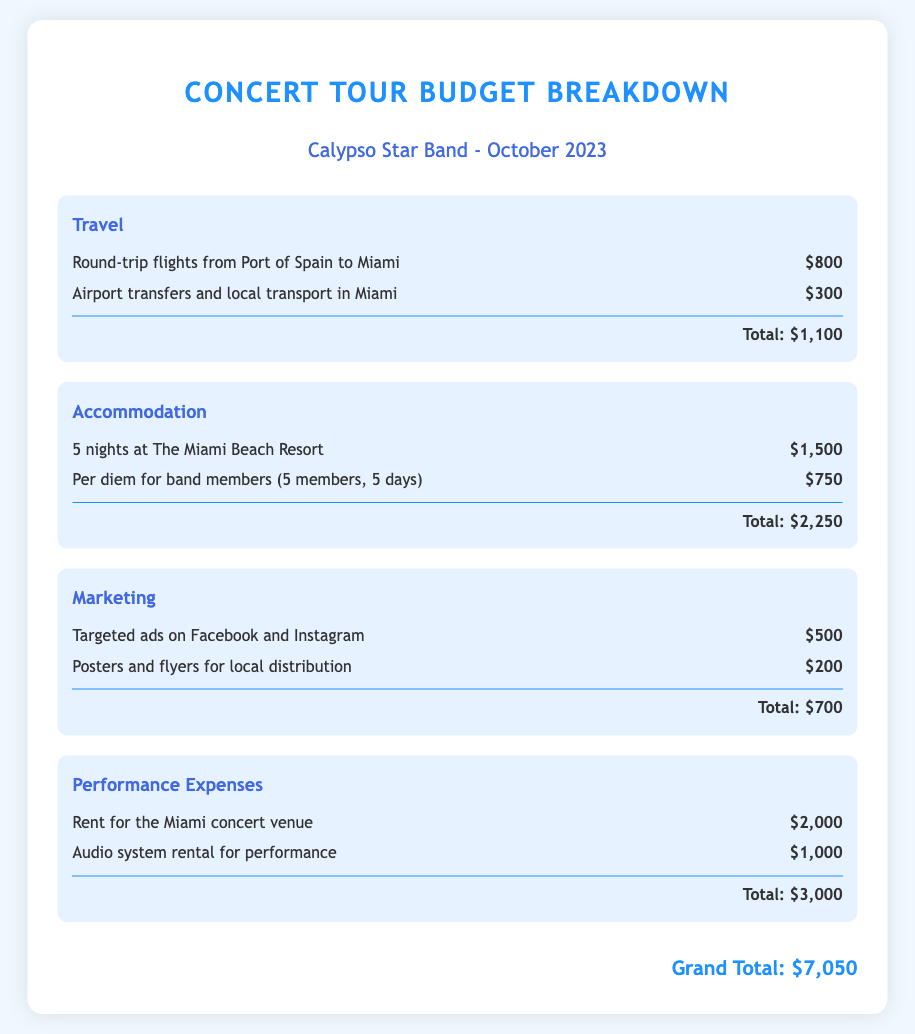What is the grand total of the concert tour budget? The grand total is summarized at the bottom of the document, totaling all expenses listed.
Answer: $7,050 How many nights are booked at The Miami Beach Resort? The accommodation section specifies the number of nights for which accommodation is secured.
Answer: 5 nights What is the cost of round-trip flights? The travel section provides the cost specifically for round-trip flights from Port of Spain to Miami.
Answer: $800 How much is allocated for local transport in Miami? The travel section mentions the specific amount budgeted for airport transfers and local transport.
Answer: $300 What is the total budget for marketing expenses? The marketing category sums up the individual marketing costs listed in the section.
Answer: $700 What is included in the performance expenses? The performance expenses section details the individual costs related to the concert venue and audio system rental.
Answer: Rent for the Miami concert venue and audio system rental How much is the per diem for band members? The accommodation section specifies the total amount allocated for per diem based on the number of band members and days.
Answer: $750 What is the cost for targeted ads on social media? The marketing section explicitly states the cost associated with targeted ads on Facebook and Instagram.
Answer: $500 What total amount is spent on accommodation? The accommodation category provides the total as the sum of different accommodation-related expenses listed.
Answer: $2,250 